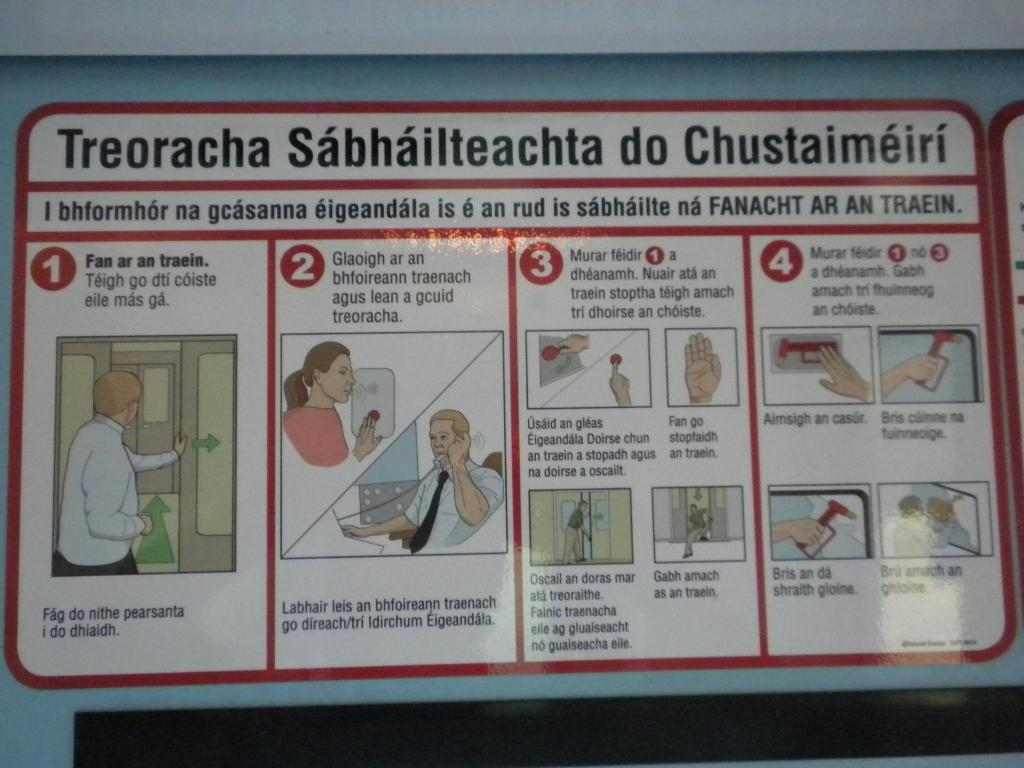What is present on the wall in the image? There is a wall in the image, and on it, there is text and cartoon pictures. Can you describe the type of content on the wall? The wall features text and cartoon pictures. What type of legal advice is the woman providing in the image? There is no woman or any indication of legal advice in the image; it only features a wall with text and cartoon pictures. 